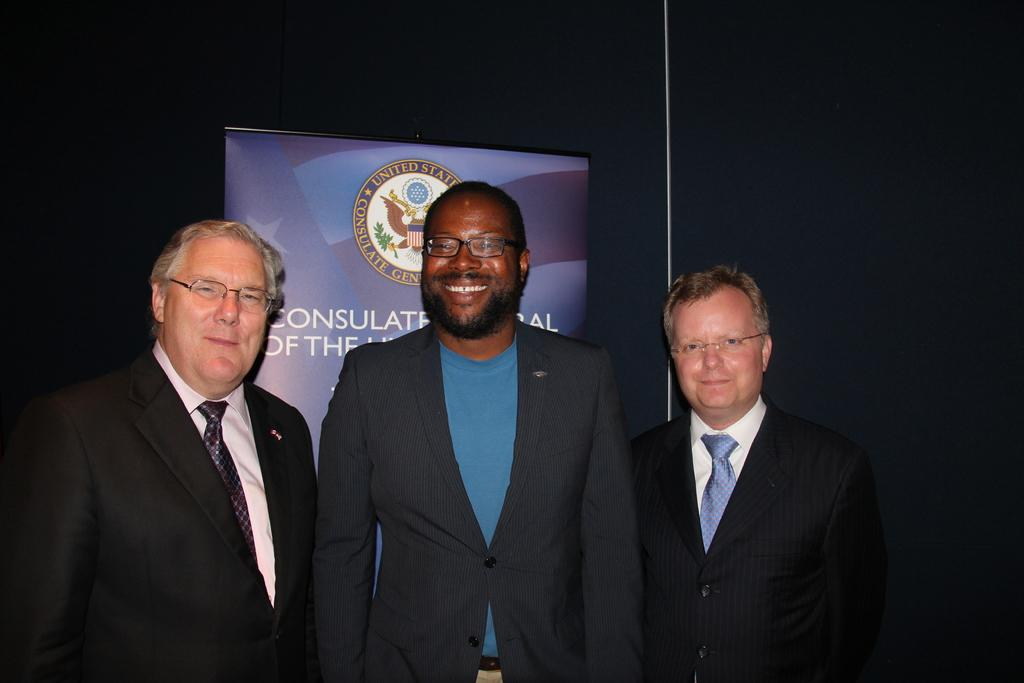How many people are present in the image? There are three people in the image. What else can be seen in the image besides the people? There is a banner with text in the image. What is the color of the background behind the people? The background of the people is black in color. What type of locket is hanging around the neck of the person in the image? There is no locket visible in the image. How many goats are present in the image? There are no goats present in the image. 